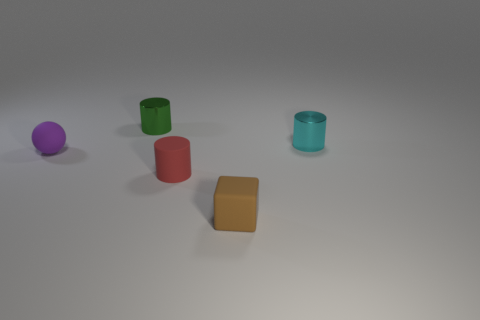There is a red rubber cylinder; what number of green cylinders are to the left of it?
Offer a very short reply. 1. What color is the thing that is made of the same material as the small cyan cylinder?
Offer a very short reply. Green. Do the red matte thing and the tiny cyan metallic object have the same shape?
Your answer should be compact. Yes. What number of objects are both in front of the cyan cylinder and on the right side of the tiny red rubber thing?
Give a very brief answer. 1. What number of matte objects are cyan blocks or cyan cylinders?
Keep it short and to the point. 0. What size is the cylinder in front of the object that is left of the tiny green shiny cylinder?
Make the answer very short. Small. Is there a tiny green shiny cylinder behind the metallic object in front of the metallic object to the left of the small matte cylinder?
Your answer should be very brief. Yes. Is the cylinder to the right of the tiny brown cube made of the same material as the object that is behind the small cyan thing?
Offer a terse response. Yes. What number of objects are either tiny red matte objects or tiny cylinders to the right of the red rubber cylinder?
Offer a terse response. 2. What number of other tiny matte things are the same shape as the brown object?
Ensure brevity in your answer.  0. 